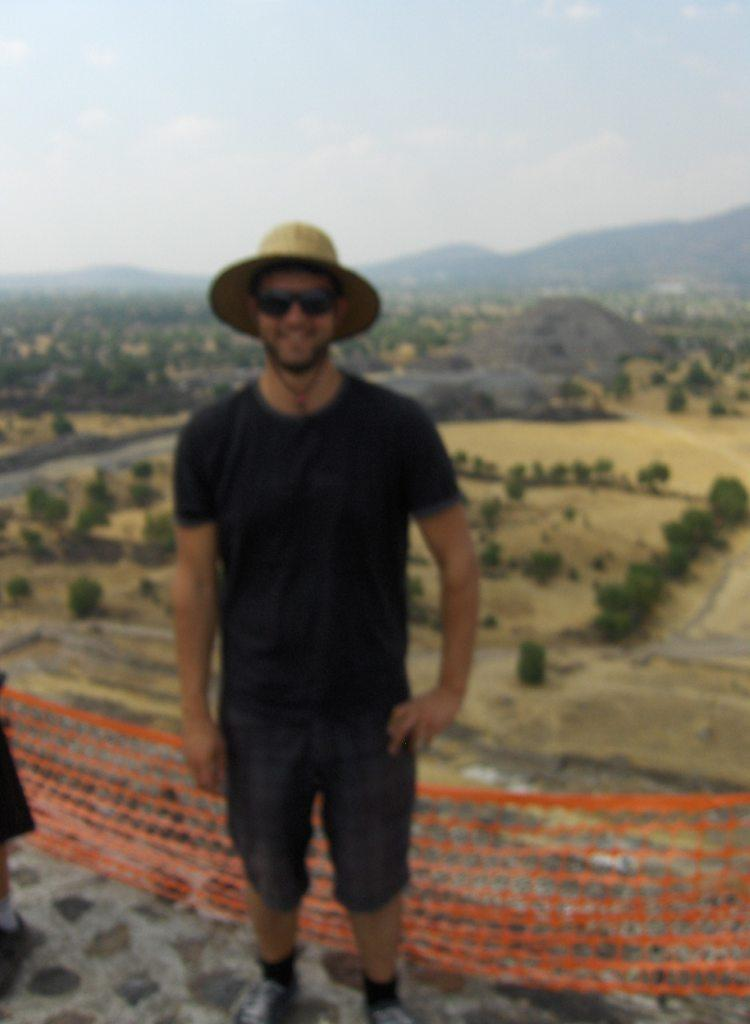What is the man in the image doing? The man in the image is smiling. What accessories is the man wearing in the image? The man is wearing goggles and a hat in the image. What can be seen in the background of the image? In the background of the image, there is a mesh, the ground, trees, a mountain, and the sky. What is the condition of the sky in the image? The sky in the image has clouds present. What type of spoon can be seen in the man's hand in the image? There is no spoon present in the man's hand or anywhere in the image. What is the man laughing at in the image? The man is not laughing in the image; he is smiling. 